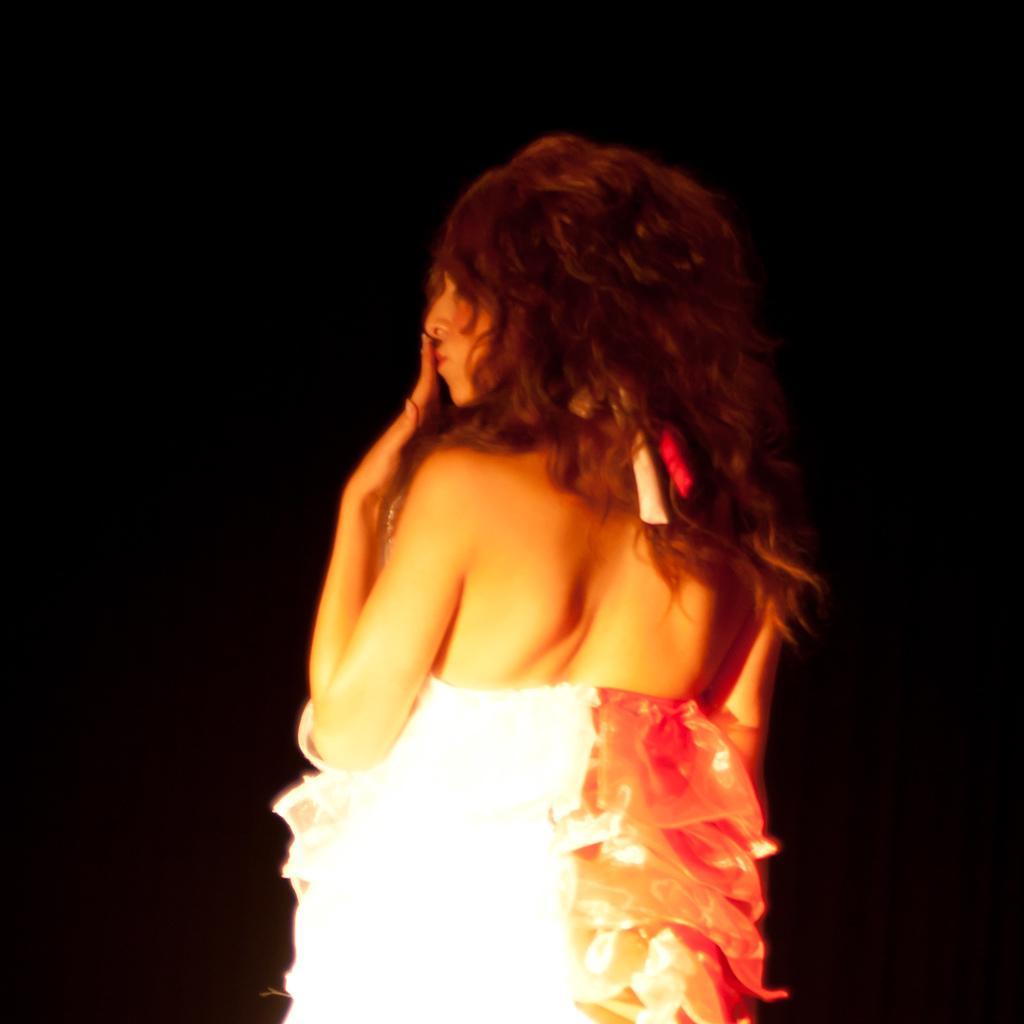Describe this image in one or two sentences. Here I can see a woman wearing white color dress and standing. The background is in black color. 